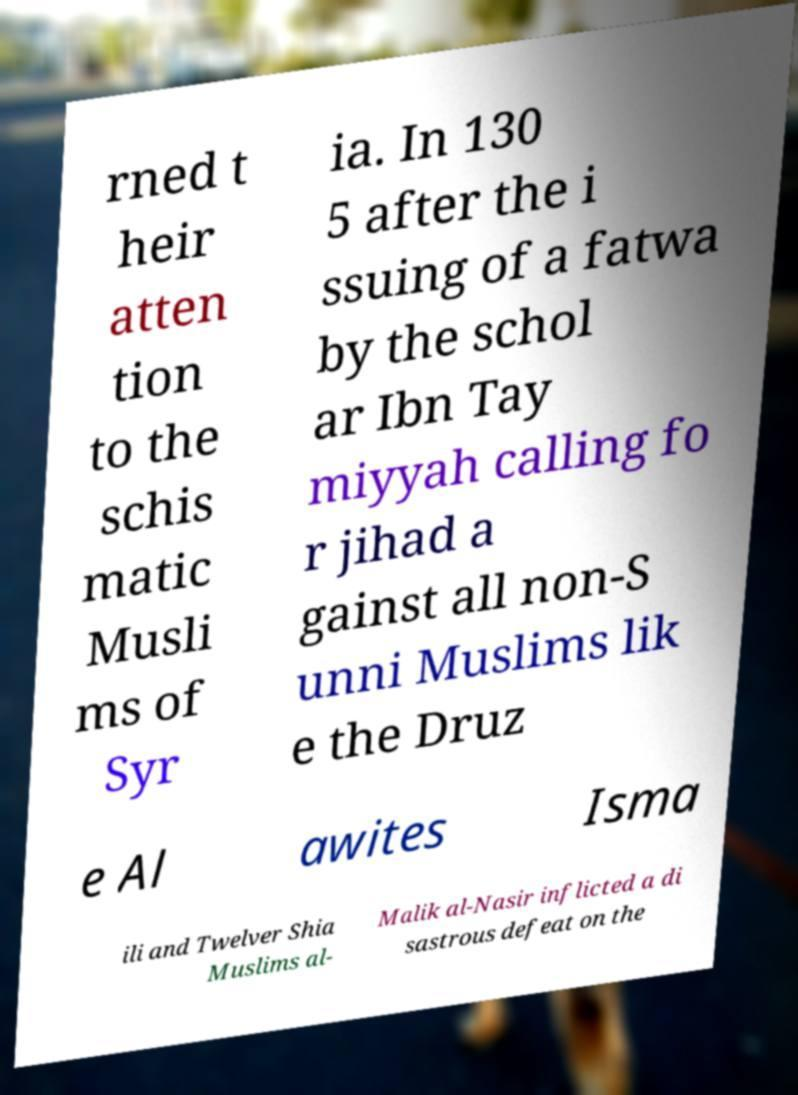Please identify and transcribe the text found in this image. rned t heir atten tion to the schis matic Musli ms of Syr ia. In 130 5 after the i ssuing of a fatwa by the schol ar Ibn Tay miyyah calling fo r jihad a gainst all non-S unni Muslims lik e the Druz e Al awites Isma ili and Twelver Shia Muslims al- Malik al-Nasir inflicted a di sastrous defeat on the 